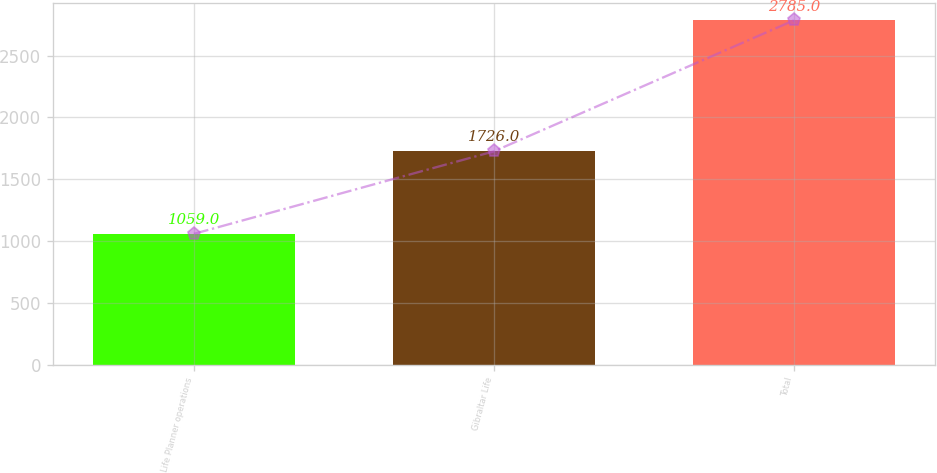<chart> <loc_0><loc_0><loc_500><loc_500><bar_chart><fcel>Life Planner operations<fcel>Gibraltar Life<fcel>Total<nl><fcel>1059<fcel>1726<fcel>2785<nl></chart> 